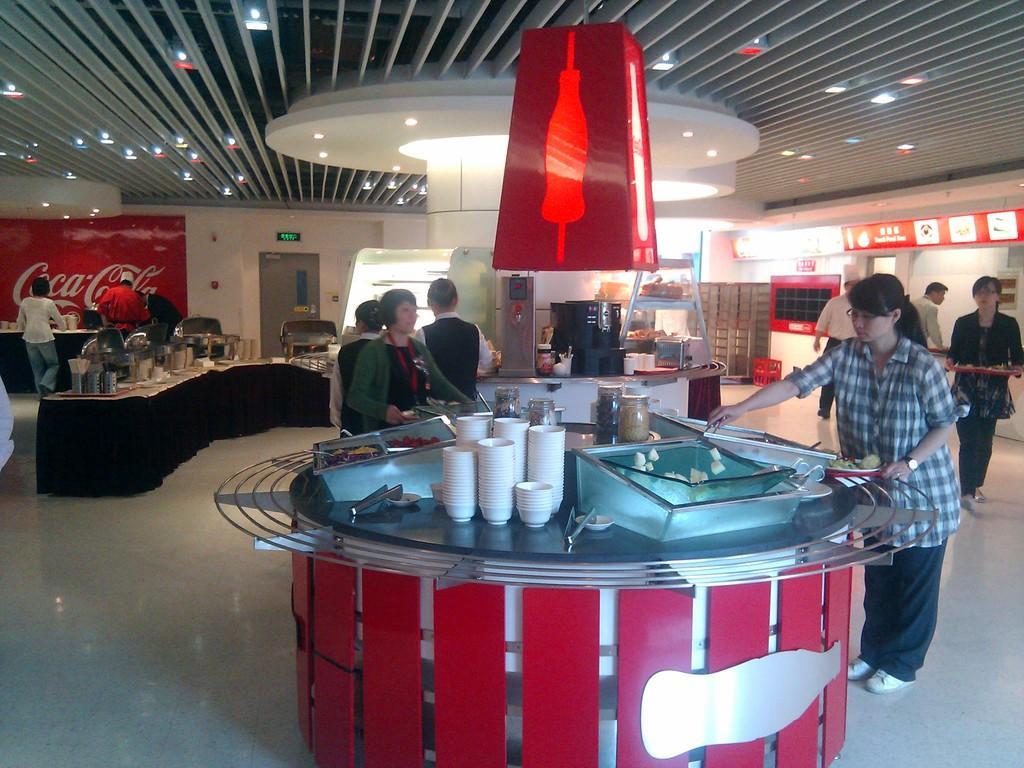In one or two sentences, can you explain what this image depicts? In this picture there is a woman who is wearing shirt, spectacle, watch and shoe. He is holding a plate and holder. She is standing near to the table. On the round table we can see a many cups, bowls, jugs, tray and food items. Beside that there are three persons were standing near to the fridge. On the right background there is a man who is standing near to the door. At the top we can see the lights and roof of the building. On the left we can see the group of persons were standing near to the table. On the table we can see the glass, bowls, plates, tissue papers, mat, spoon, fox and other objects. back side of the table there is a exit door. 